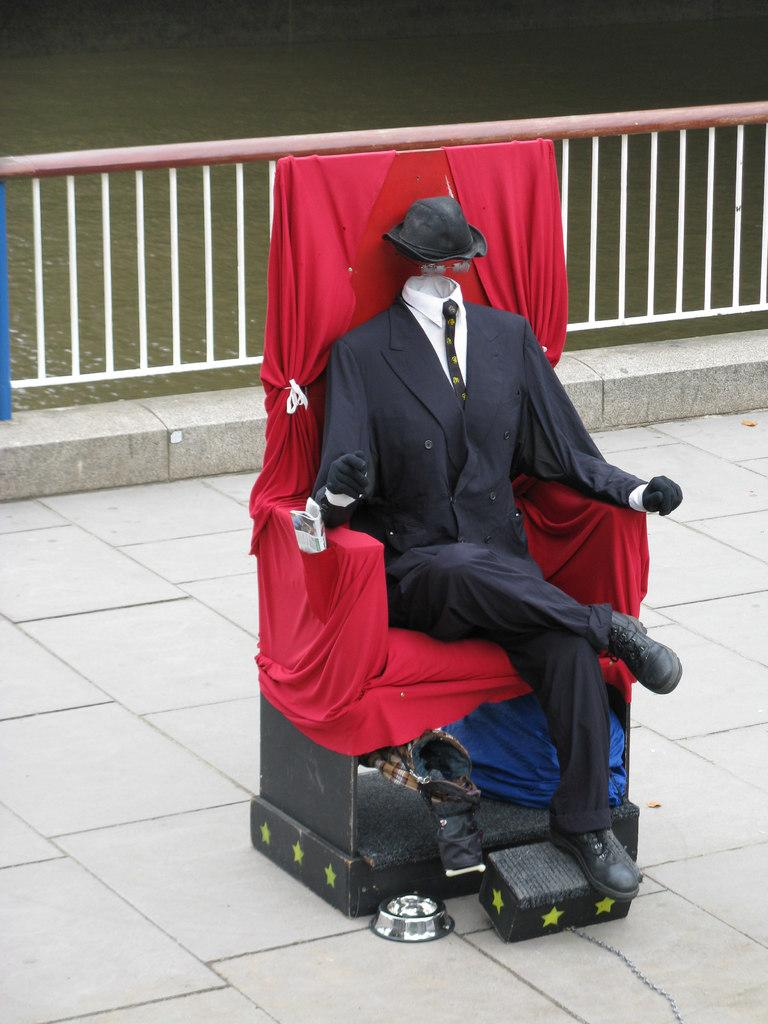What is the main object in the image? There is a mannequin in the image. Where is the mannequin located? The mannequin is on a chair. What else can be seen in the image besides the mannequin? There are clothes in the image. What architectural feature is visible at the back side of the image? There is a railing at the back side of the image. What natural element is visible at the top of the image? There is water visible at the top of the image. How many babies are performing magic tricks in the image? There are no babies or magic tricks present in the image. What type of card is the mannequin holding in the image? There is no card present in the image; the mannequin is not holding anything. 